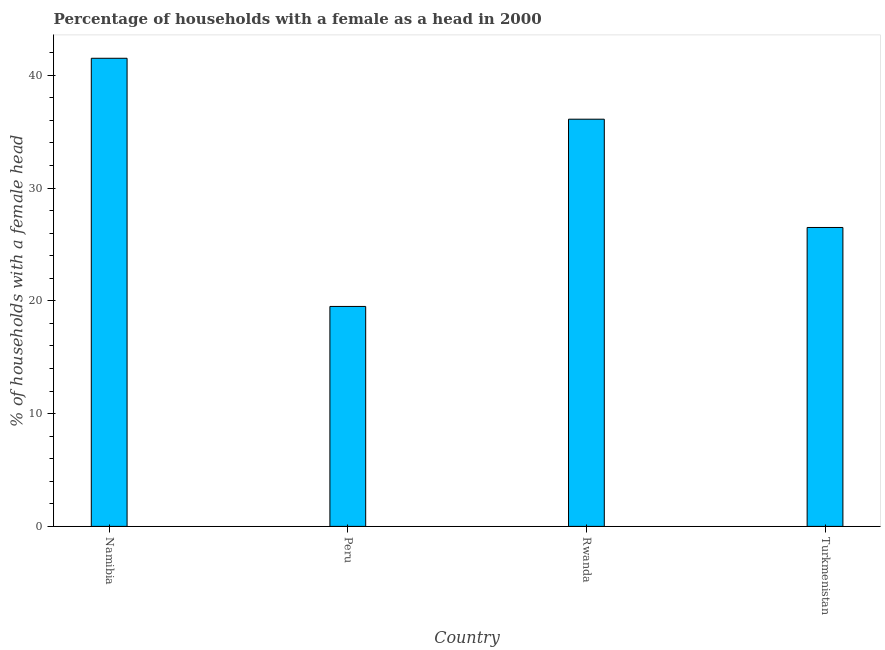Does the graph contain grids?
Your response must be concise. No. What is the title of the graph?
Ensure brevity in your answer.  Percentage of households with a female as a head in 2000. What is the label or title of the X-axis?
Your answer should be very brief. Country. What is the label or title of the Y-axis?
Your response must be concise. % of households with a female head. What is the number of female supervised households in Rwanda?
Offer a terse response. 36.1. Across all countries, what is the maximum number of female supervised households?
Provide a succinct answer. 41.5. Across all countries, what is the minimum number of female supervised households?
Provide a short and direct response. 19.5. In which country was the number of female supervised households maximum?
Your answer should be very brief. Namibia. In which country was the number of female supervised households minimum?
Ensure brevity in your answer.  Peru. What is the sum of the number of female supervised households?
Ensure brevity in your answer.  123.6. What is the difference between the number of female supervised households in Peru and Turkmenistan?
Offer a very short reply. -7. What is the average number of female supervised households per country?
Keep it short and to the point. 30.9. What is the median number of female supervised households?
Give a very brief answer. 31.3. In how many countries, is the number of female supervised households greater than 10 %?
Make the answer very short. 4. What is the ratio of the number of female supervised households in Namibia to that in Rwanda?
Your answer should be compact. 1.15. Is the number of female supervised households in Namibia less than that in Turkmenistan?
Ensure brevity in your answer.  No. What is the difference between the highest and the second highest number of female supervised households?
Provide a succinct answer. 5.4. Is the sum of the number of female supervised households in Namibia and Turkmenistan greater than the maximum number of female supervised households across all countries?
Keep it short and to the point. Yes. What is the difference between the highest and the lowest number of female supervised households?
Your answer should be compact. 22. How many bars are there?
Your response must be concise. 4. What is the difference between two consecutive major ticks on the Y-axis?
Ensure brevity in your answer.  10. Are the values on the major ticks of Y-axis written in scientific E-notation?
Your answer should be compact. No. What is the % of households with a female head of Namibia?
Make the answer very short. 41.5. What is the % of households with a female head of Peru?
Provide a short and direct response. 19.5. What is the % of households with a female head in Rwanda?
Provide a succinct answer. 36.1. What is the % of households with a female head of Turkmenistan?
Offer a very short reply. 26.5. What is the difference between the % of households with a female head in Namibia and Peru?
Provide a succinct answer. 22. What is the difference between the % of households with a female head in Namibia and Rwanda?
Provide a short and direct response. 5.4. What is the difference between the % of households with a female head in Peru and Rwanda?
Your answer should be very brief. -16.6. What is the difference between the % of households with a female head in Rwanda and Turkmenistan?
Your response must be concise. 9.6. What is the ratio of the % of households with a female head in Namibia to that in Peru?
Give a very brief answer. 2.13. What is the ratio of the % of households with a female head in Namibia to that in Rwanda?
Provide a short and direct response. 1.15. What is the ratio of the % of households with a female head in Namibia to that in Turkmenistan?
Provide a succinct answer. 1.57. What is the ratio of the % of households with a female head in Peru to that in Rwanda?
Your answer should be compact. 0.54. What is the ratio of the % of households with a female head in Peru to that in Turkmenistan?
Ensure brevity in your answer.  0.74. What is the ratio of the % of households with a female head in Rwanda to that in Turkmenistan?
Ensure brevity in your answer.  1.36. 